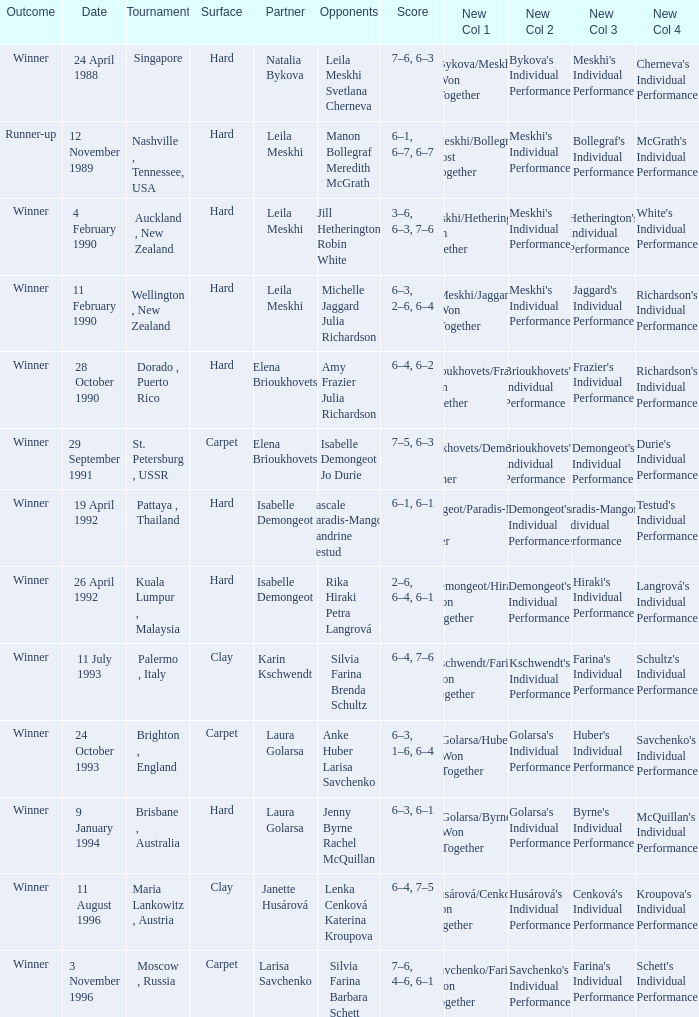In what Tournament was the Score of 3–6, 6–3, 7–6 in a match played on a hard Surface? Auckland , New Zealand. 